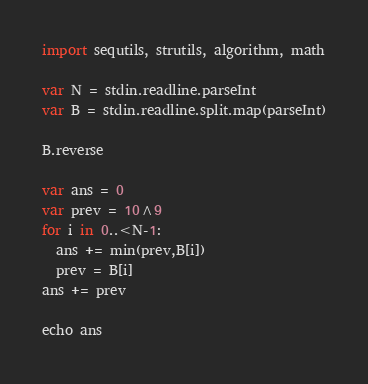Convert code to text. <code><loc_0><loc_0><loc_500><loc_500><_Nim_>import sequtils, strutils, algorithm, math

var N = stdin.readline.parseInt
var B = stdin.readline.split.map(parseInt)

B.reverse

var ans = 0
var prev = 10^9
for i in 0..<N-1:
  ans += min(prev,B[i])
  prev = B[i]
ans += prev

echo ans </code> 